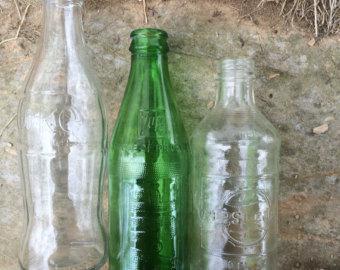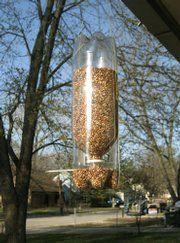The first image is the image on the left, the second image is the image on the right. Given the left and right images, does the statement "There are three glass bottles in the left image." hold true? Answer yes or no. Yes. The first image is the image on the left, the second image is the image on the right. Considering the images on both sides, is "There are at most 3 bottles in the image pair." valid? Answer yes or no. No. 